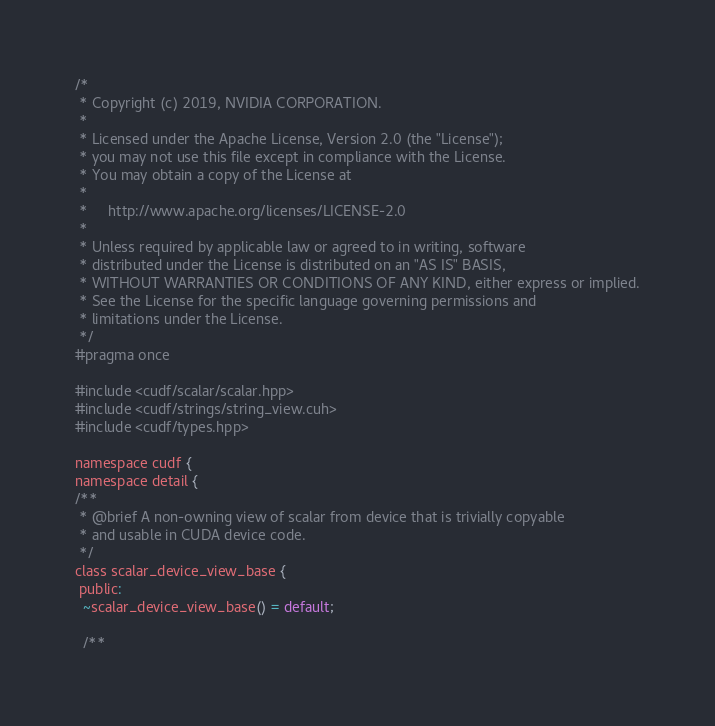Convert code to text. <code><loc_0><loc_0><loc_500><loc_500><_Cuda_>/*
 * Copyright (c) 2019, NVIDIA CORPORATION.
 *
 * Licensed under the Apache License, Version 2.0 (the "License");
 * you may not use this file except in compliance with the License.
 * You may obtain a copy of the License at
 *
 *     http://www.apache.org/licenses/LICENSE-2.0
 *
 * Unless required by applicable law or agreed to in writing, software
 * distributed under the License is distributed on an "AS IS" BASIS,
 * WITHOUT WARRANTIES OR CONDITIONS OF ANY KIND, either express or implied.
 * See the License for the specific language governing permissions and
 * limitations under the License.
 */
#pragma once

#include <cudf/scalar/scalar.hpp>
#include <cudf/strings/string_view.cuh>
#include <cudf/types.hpp>

namespace cudf {
namespace detail {
/**
 * @brief A non-owning view of scalar from device that is trivially copyable
 * and usable in CUDA device code.
 */
class scalar_device_view_base {
 public:
  ~scalar_device_view_base() = default;

  /**</code> 